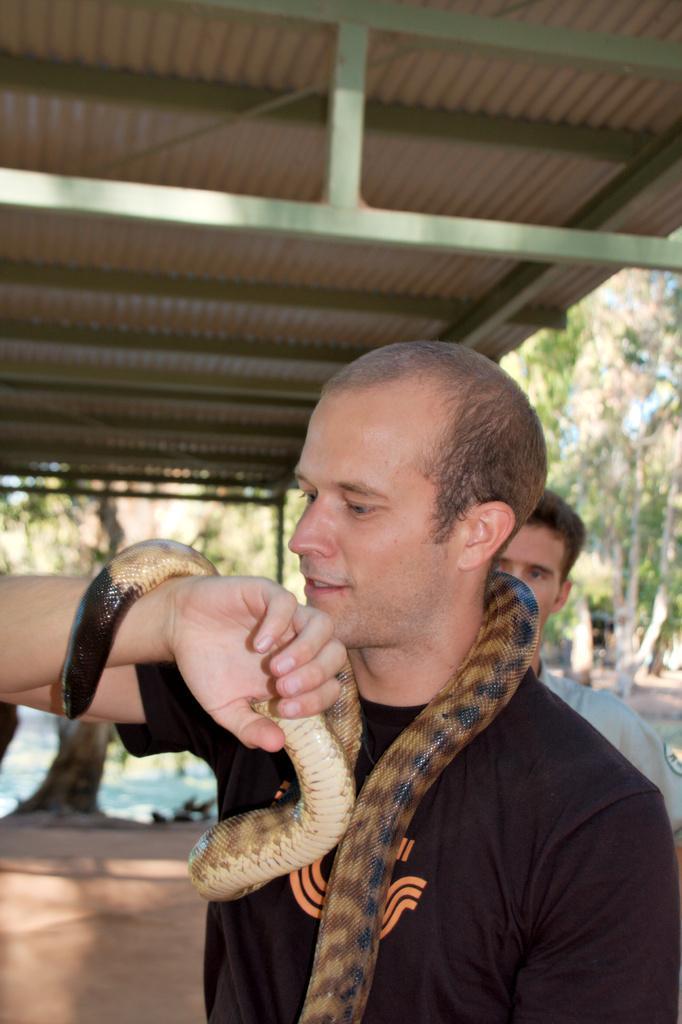Could you give a brief overview of what you see in this image? This picture is taken outside a building. In the middle there is a person wearing a black t shirt looking at the snake. He put the snake on his neck and hand. Behind him another person is standing and looking at him. On top of them there is roof. In the background there are trees. 